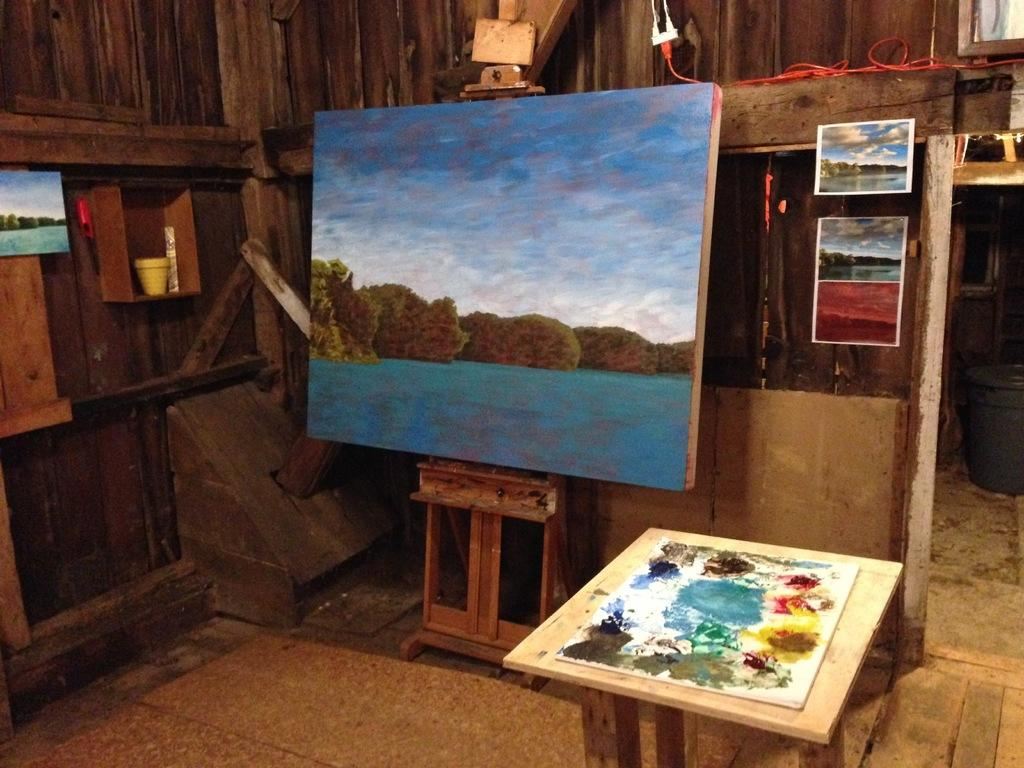What is the main object in the image? There is a painting board in the image. What else can be seen near the painting board? There are posters beside the painting board. What type of wall is visible in the background of the image? There is a wooden wall in the background of the image. What materials are used for painting in the image? There are paints visible in the image. How many rings does the mom have on her eyes in the image? There is no mom or rings on eyes present in the image. 